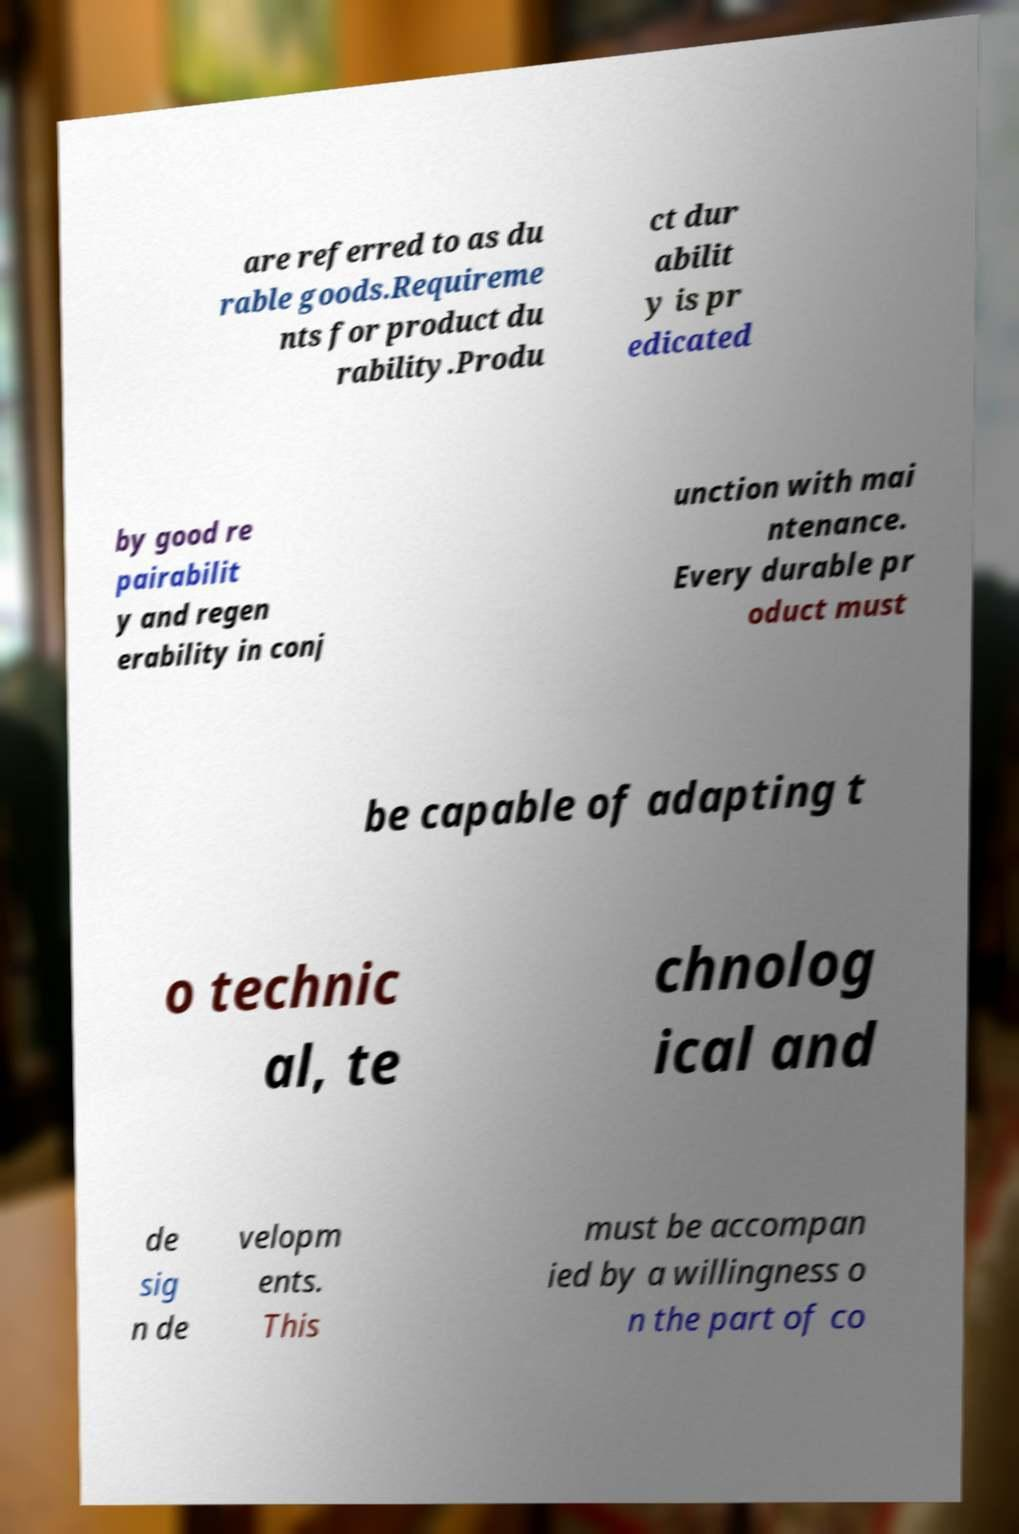Can you accurately transcribe the text from the provided image for me? are referred to as du rable goods.Requireme nts for product du rability.Produ ct dur abilit y is pr edicated by good re pairabilit y and regen erability in conj unction with mai ntenance. Every durable pr oduct must be capable of adapting t o technic al, te chnolog ical and de sig n de velopm ents. This must be accompan ied by a willingness o n the part of co 